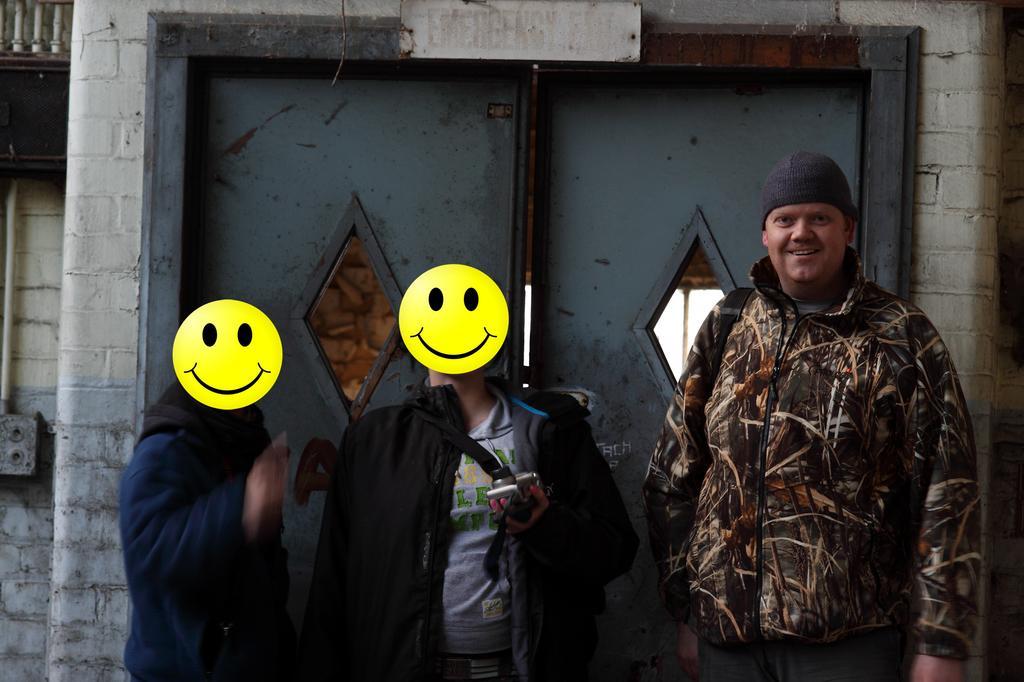Can you describe this image briefly? This is an edited picture. I can see three persons standing, there is a person holding a camera, and in the background there is a door and a board. 